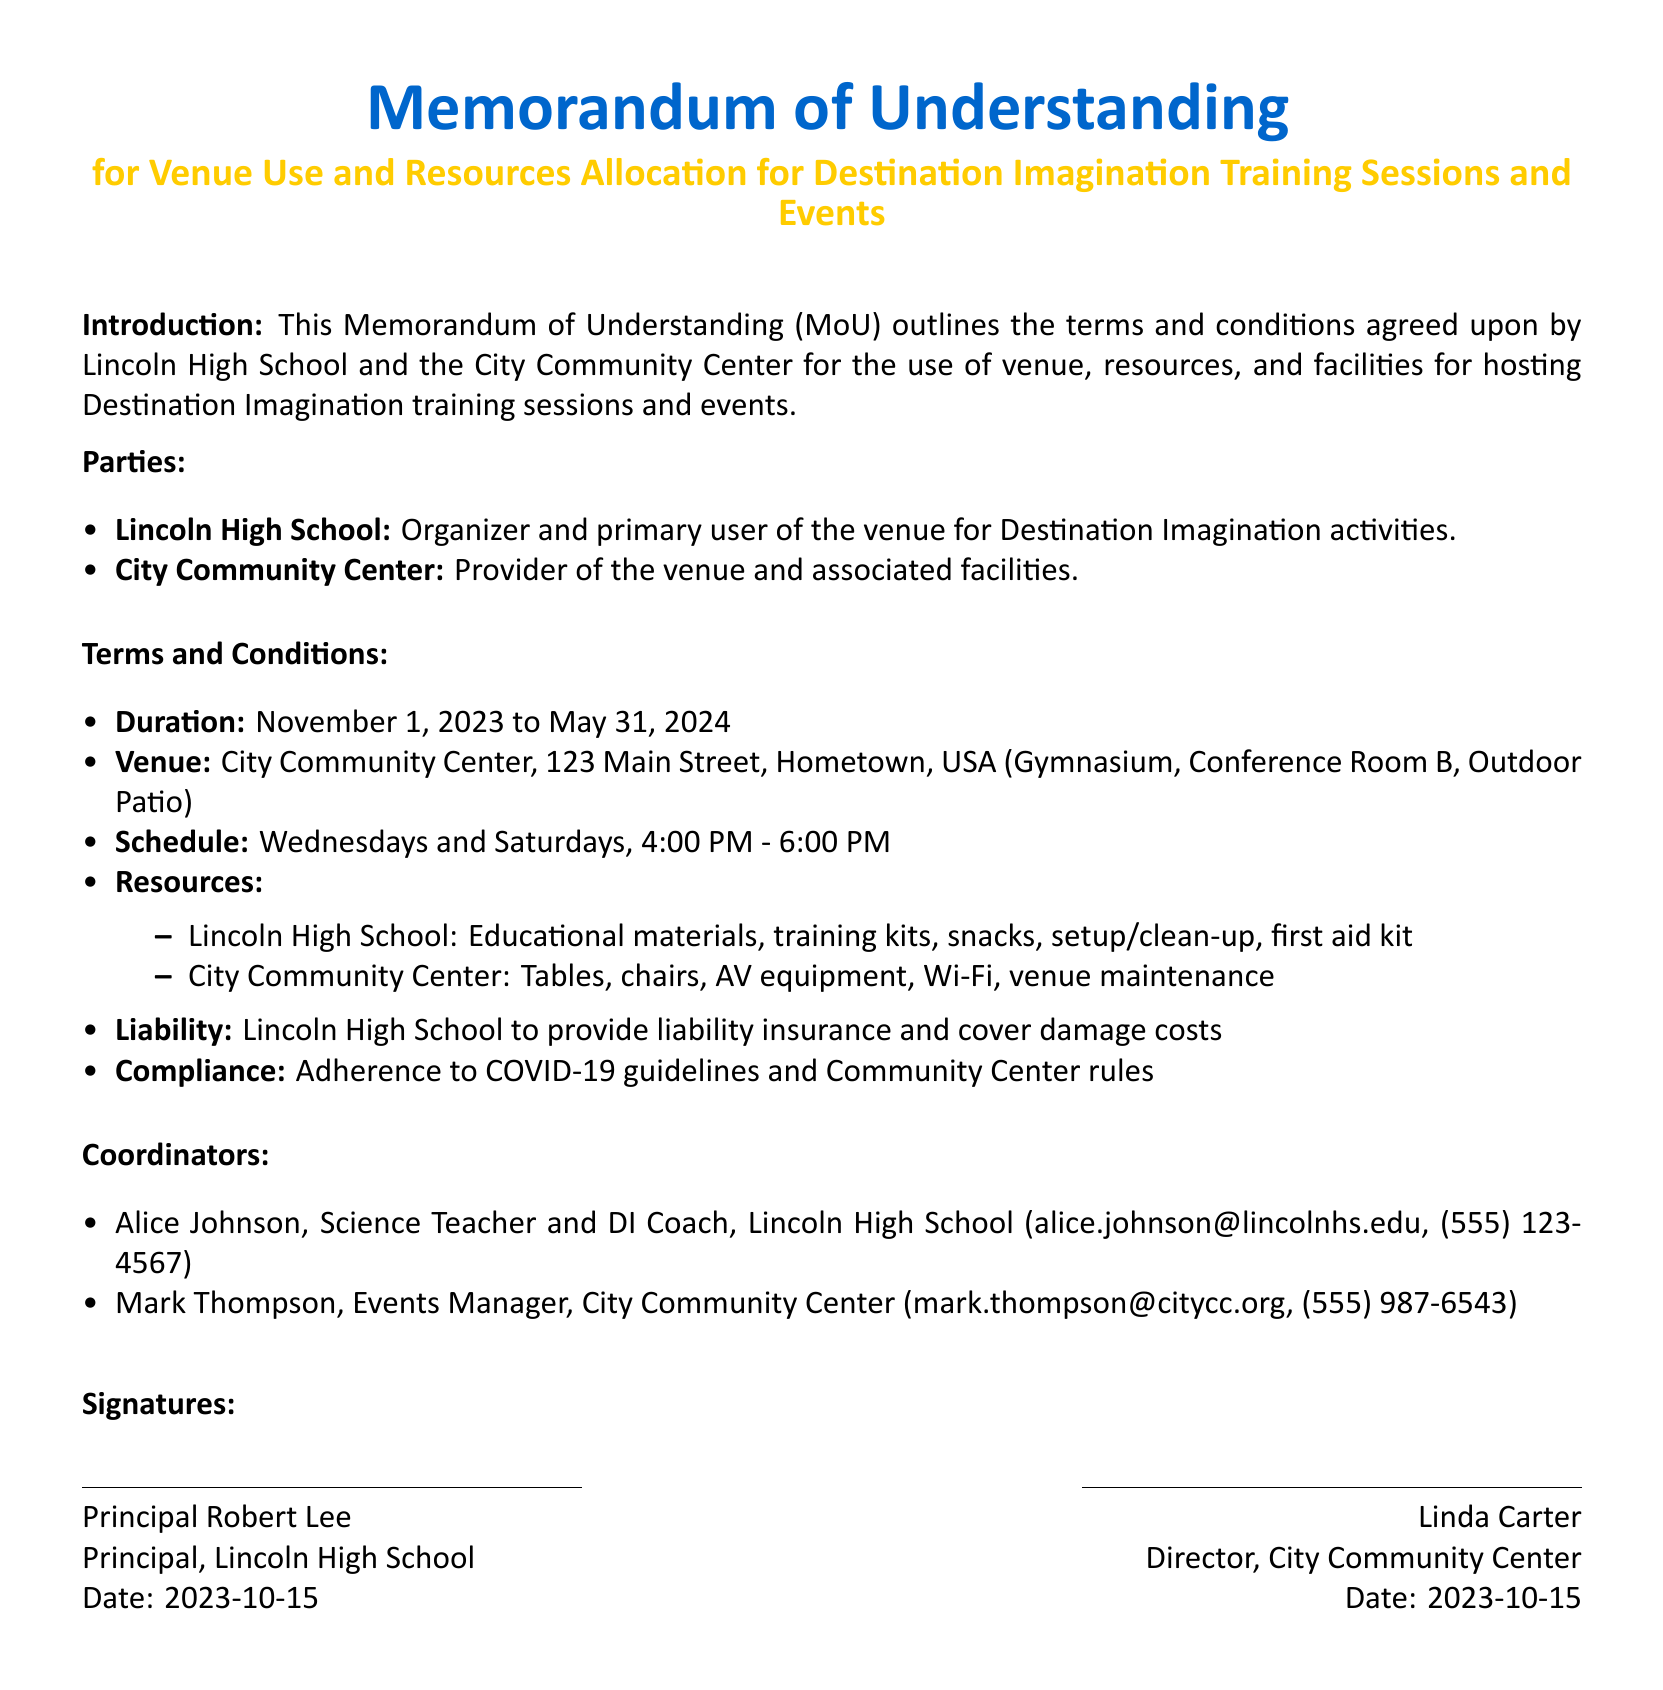what is the duration of the agreement? The duration of the agreement is outlined in the terms and conditions section, specified as November 1, 2023 to May 31, 2024.
Answer: November 1, 2023 to May 31, 2024 who is the primary user of the venue? The document states that Lincoln High School is the organizer and primary user of the venue for Destination Imagination activities.
Answer: Lincoln High School where is the City Community Center located? The address of the City Community Center is provided as 123 Main Street, Hometown, USA.
Answer: 123 Main Street, Hometown, USA on which days are the training sessions scheduled? The schedule section specifies that the training sessions are held on Wednesdays and Saturdays.
Answer: Wednesdays and Saturdays what resources are provided by Lincoln High School? The resources provided by Lincoln High School include educational materials, training kits, snacks, setup/clean-up, and first aid kit.
Answer: Educational materials, training kits, snacks, setup/clean-up, first aid kit who are the coordinators mentioned in the document? The document lists Alice Johnson and Mark Thompson as the coordinators for the respective parties.
Answer: Alice Johnson, Mark Thompson what is the liability insurance requirement stated? The liability section specifies that Lincoln High School is to provide liability insurance and cover damage costs.
Answer: Provide liability insurance and cover damage costs what are the event times for training sessions? The terms and conditions specify that the events are scheduled from 4:00 PM to 6:00 PM.
Answer: 4:00 PM - 6:00 PM what must be adhered to according to the compliance section? The compliance section states adherence to COVID-19 guidelines and Community Center rules is required.
Answer: COVID-19 guidelines and Community Center rules 